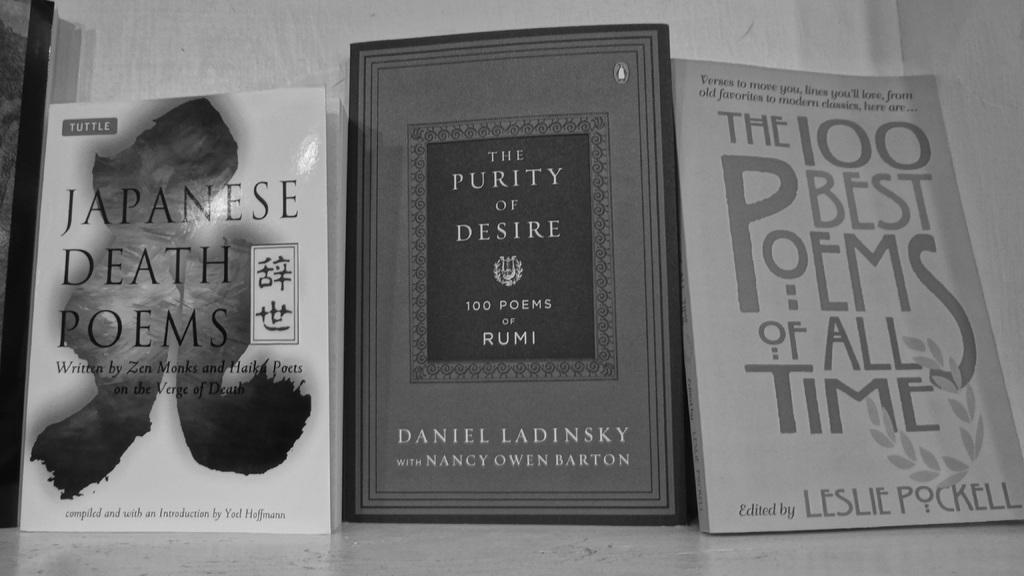<image>
Provide a brief description of the given image. A collection of three poem books with the covers facing up. 